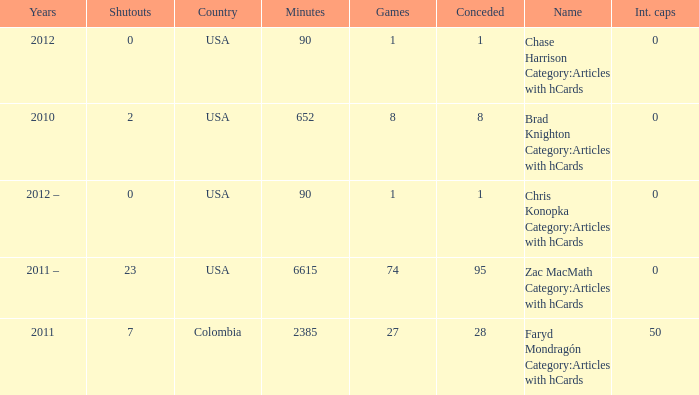When  chris konopka category:articles with hcards is the name what is the year? 2012 –. 